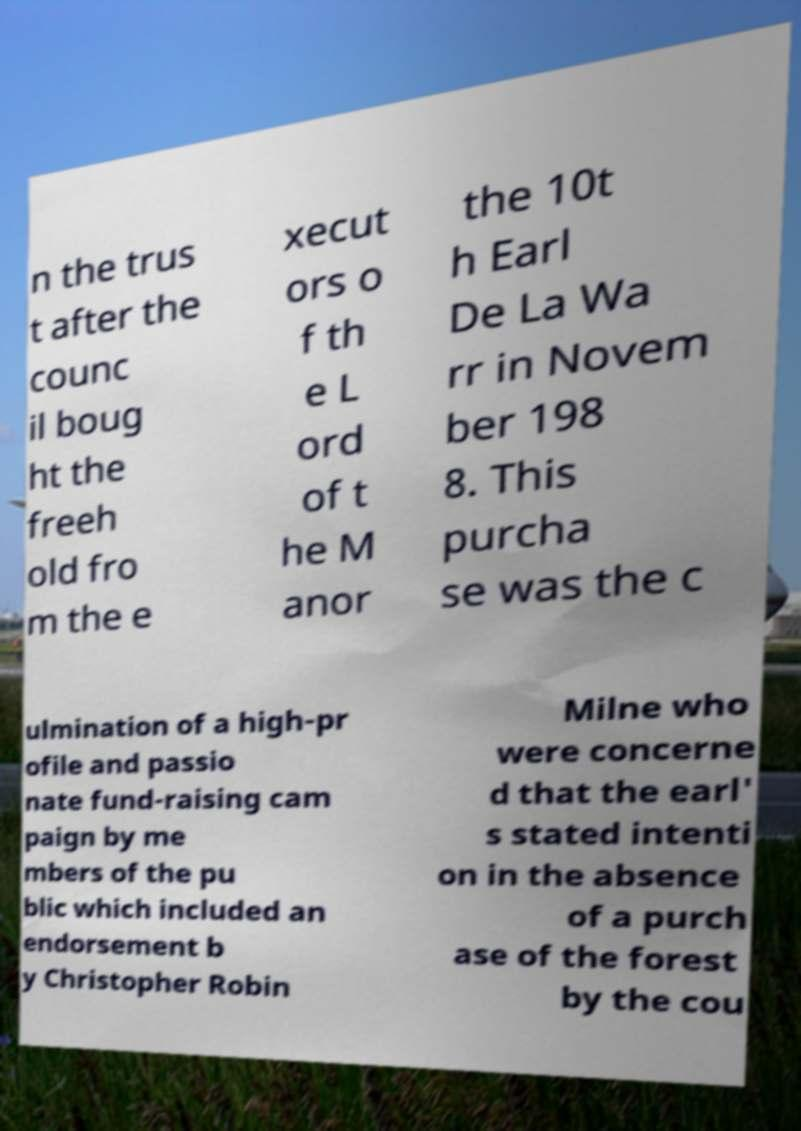I need the written content from this picture converted into text. Can you do that? n the trus t after the counc il boug ht the freeh old fro m the e xecut ors o f th e L ord of t he M anor the 10t h Earl De La Wa rr in Novem ber 198 8. This purcha se was the c ulmination of a high-pr ofile and passio nate fund-raising cam paign by me mbers of the pu blic which included an endorsement b y Christopher Robin Milne who were concerne d that the earl' s stated intenti on in the absence of a purch ase of the forest by the cou 